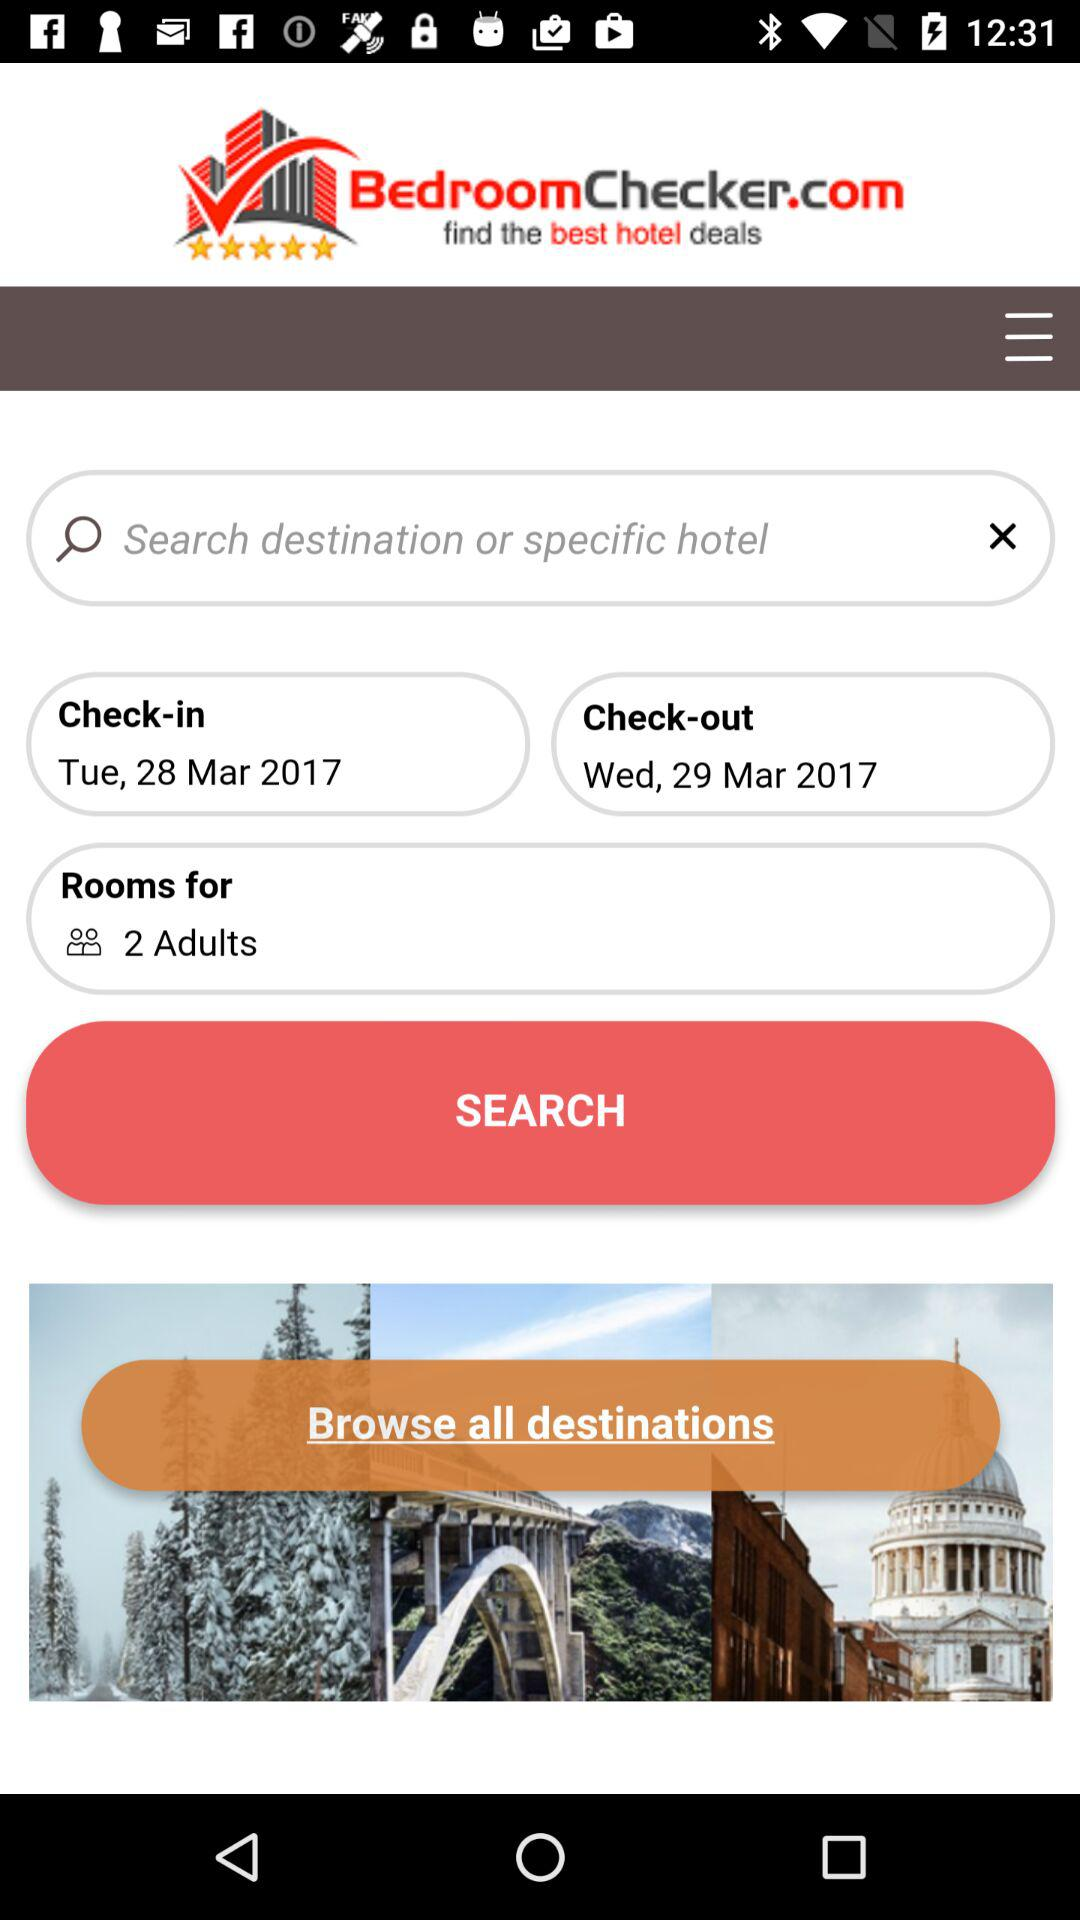For how many adults has the room been booked? The room has been booked for 2 adults. 